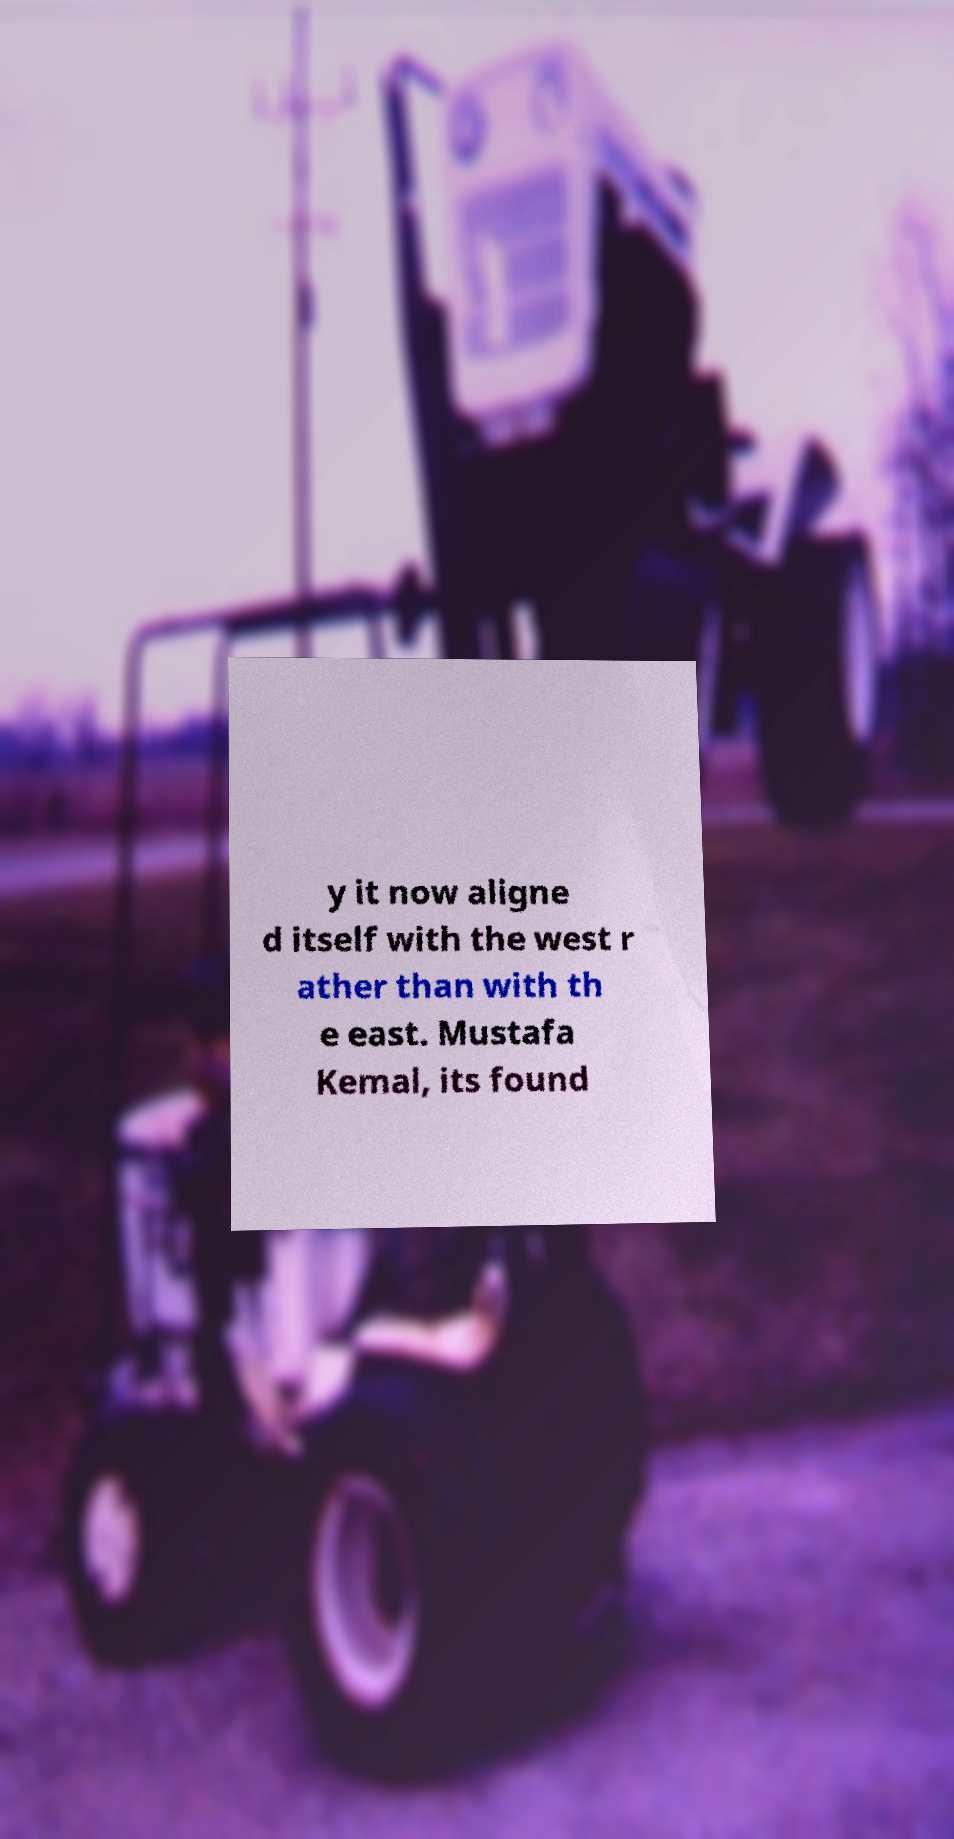Please read and relay the text visible in this image. What does it say? y it now aligne d itself with the west r ather than with th e east. Mustafa Kemal, its found 